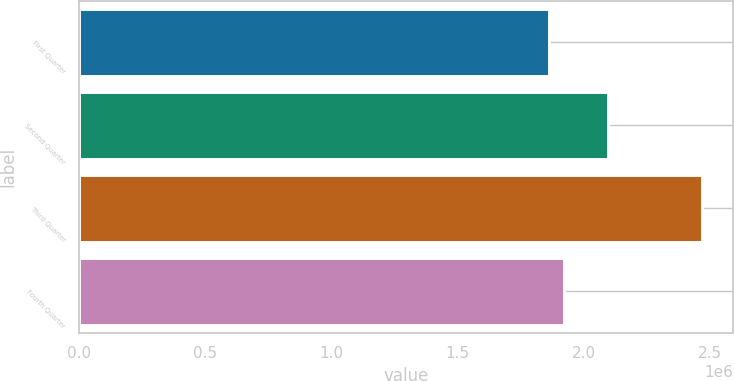Convert chart to OTSL. <chart><loc_0><loc_0><loc_500><loc_500><bar_chart><fcel>First Quarter<fcel>Second Quarter<fcel>Third Quarter<fcel>Fourth Quarter<nl><fcel>1.86083e+06<fcel>2.09658e+06<fcel>2.46888e+06<fcel>1.92164e+06<nl></chart> 